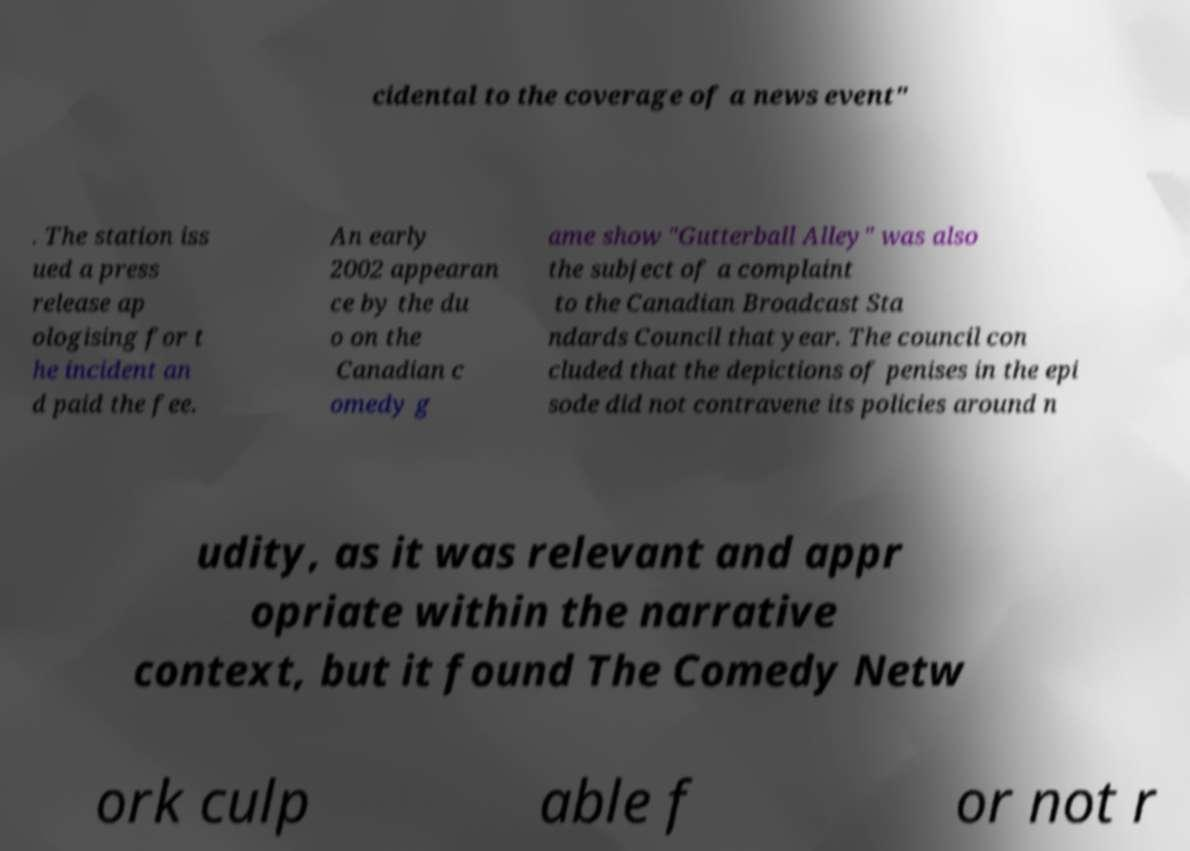Please read and relay the text visible in this image. What does it say? cidental to the coverage of a news event" . The station iss ued a press release ap ologising for t he incident an d paid the fee. An early 2002 appearan ce by the du o on the Canadian c omedy g ame show "Gutterball Alley" was also the subject of a complaint to the Canadian Broadcast Sta ndards Council that year. The council con cluded that the depictions of penises in the epi sode did not contravene its policies around n udity, as it was relevant and appr opriate within the narrative context, but it found The Comedy Netw ork culp able f or not r 